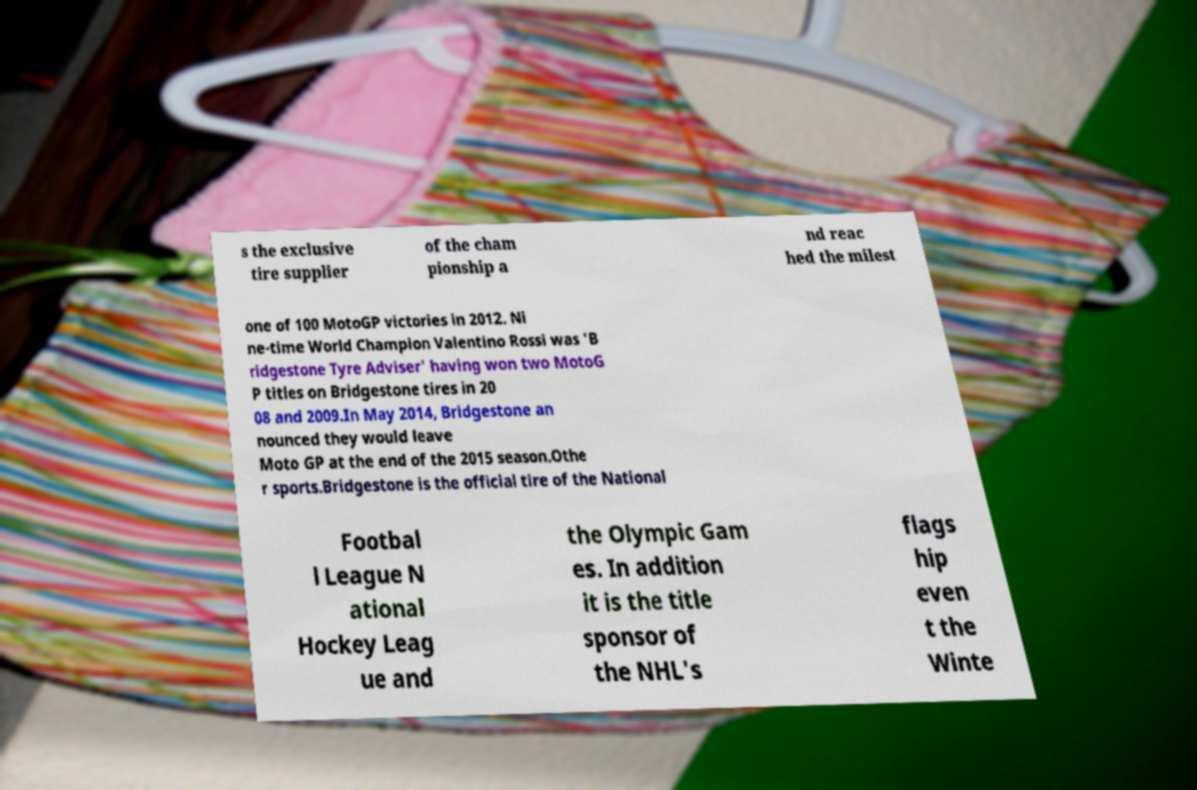Please identify and transcribe the text found in this image. s the exclusive tire supplier of the cham pionship a nd reac hed the milest one of 100 MotoGP victories in 2012. Ni ne-time World Champion Valentino Rossi was 'B ridgestone Tyre Adviser' having won two MotoG P titles on Bridgestone tires in 20 08 and 2009.In May 2014, Bridgestone an nounced they would leave Moto GP at the end of the 2015 season.Othe r sports.Bridgestone is the official tire of the National Footbal l League N ational Hockey Leag ue and the Olympic Gam es. In addition it is the title sponsor of the NHL's flags hip even t the Winte 